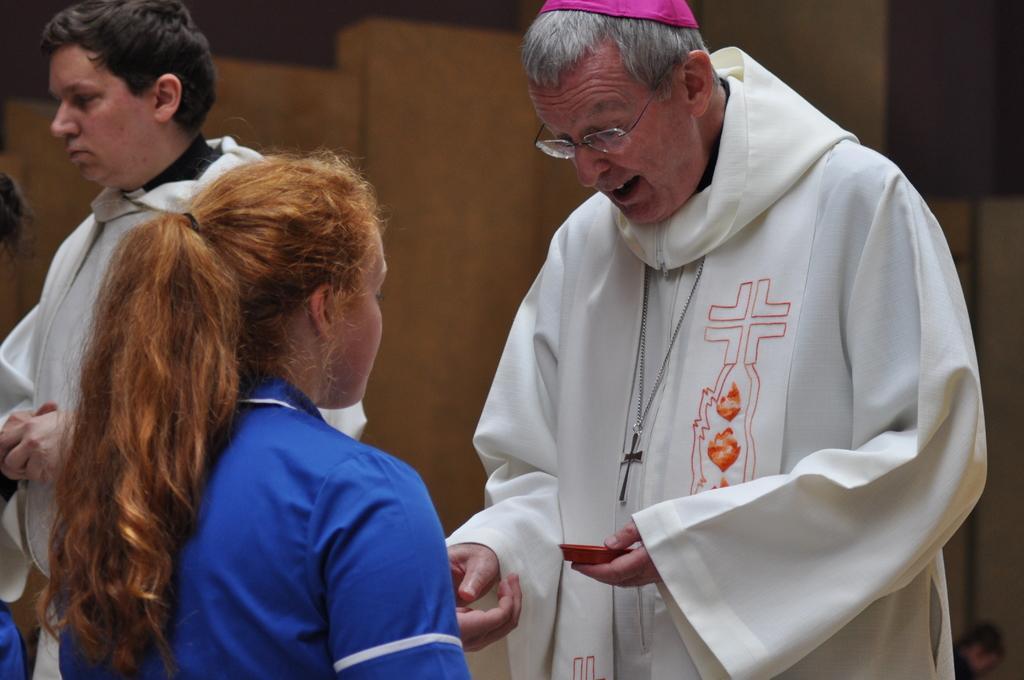Could you give a brief overview of what you see in this image? In this picture we can see a group people standing on the path and a man in the white dress is holding an object and behind the people there is an object and a dark background. 